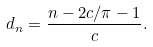<formula> <loc_0><loc_0><loc_500><loc_500>d _ { n } = \frac { n - 2 c / \pi - 1 } { c } .</formula> 